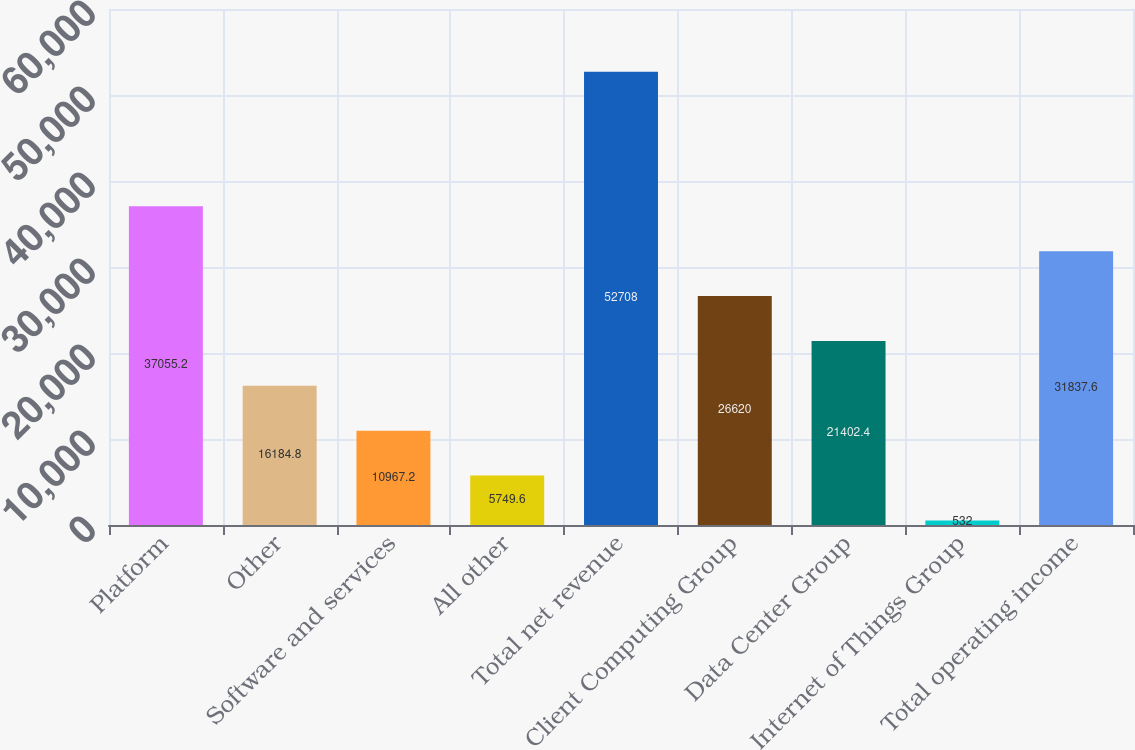Convert chart. <chart><loc_0><loc_0><loc_500><loc_500><bar_chart><fcel>Platform<fcel>Other<fcel>Software and services<fcel>All other<fcel>Total net revenue<fcel>Client Computing Group<fcel>Data Center Group<fcel>Internet of Things Group<fcel>Total operating income<nl><fcel>37055.2<fcel>16184.8<fcel>10967.2<fcel>5749.6<fcel>52708<fcel>26620<fcel>21402.4<fcel>532<fcel>31837.6<nl></chart> 